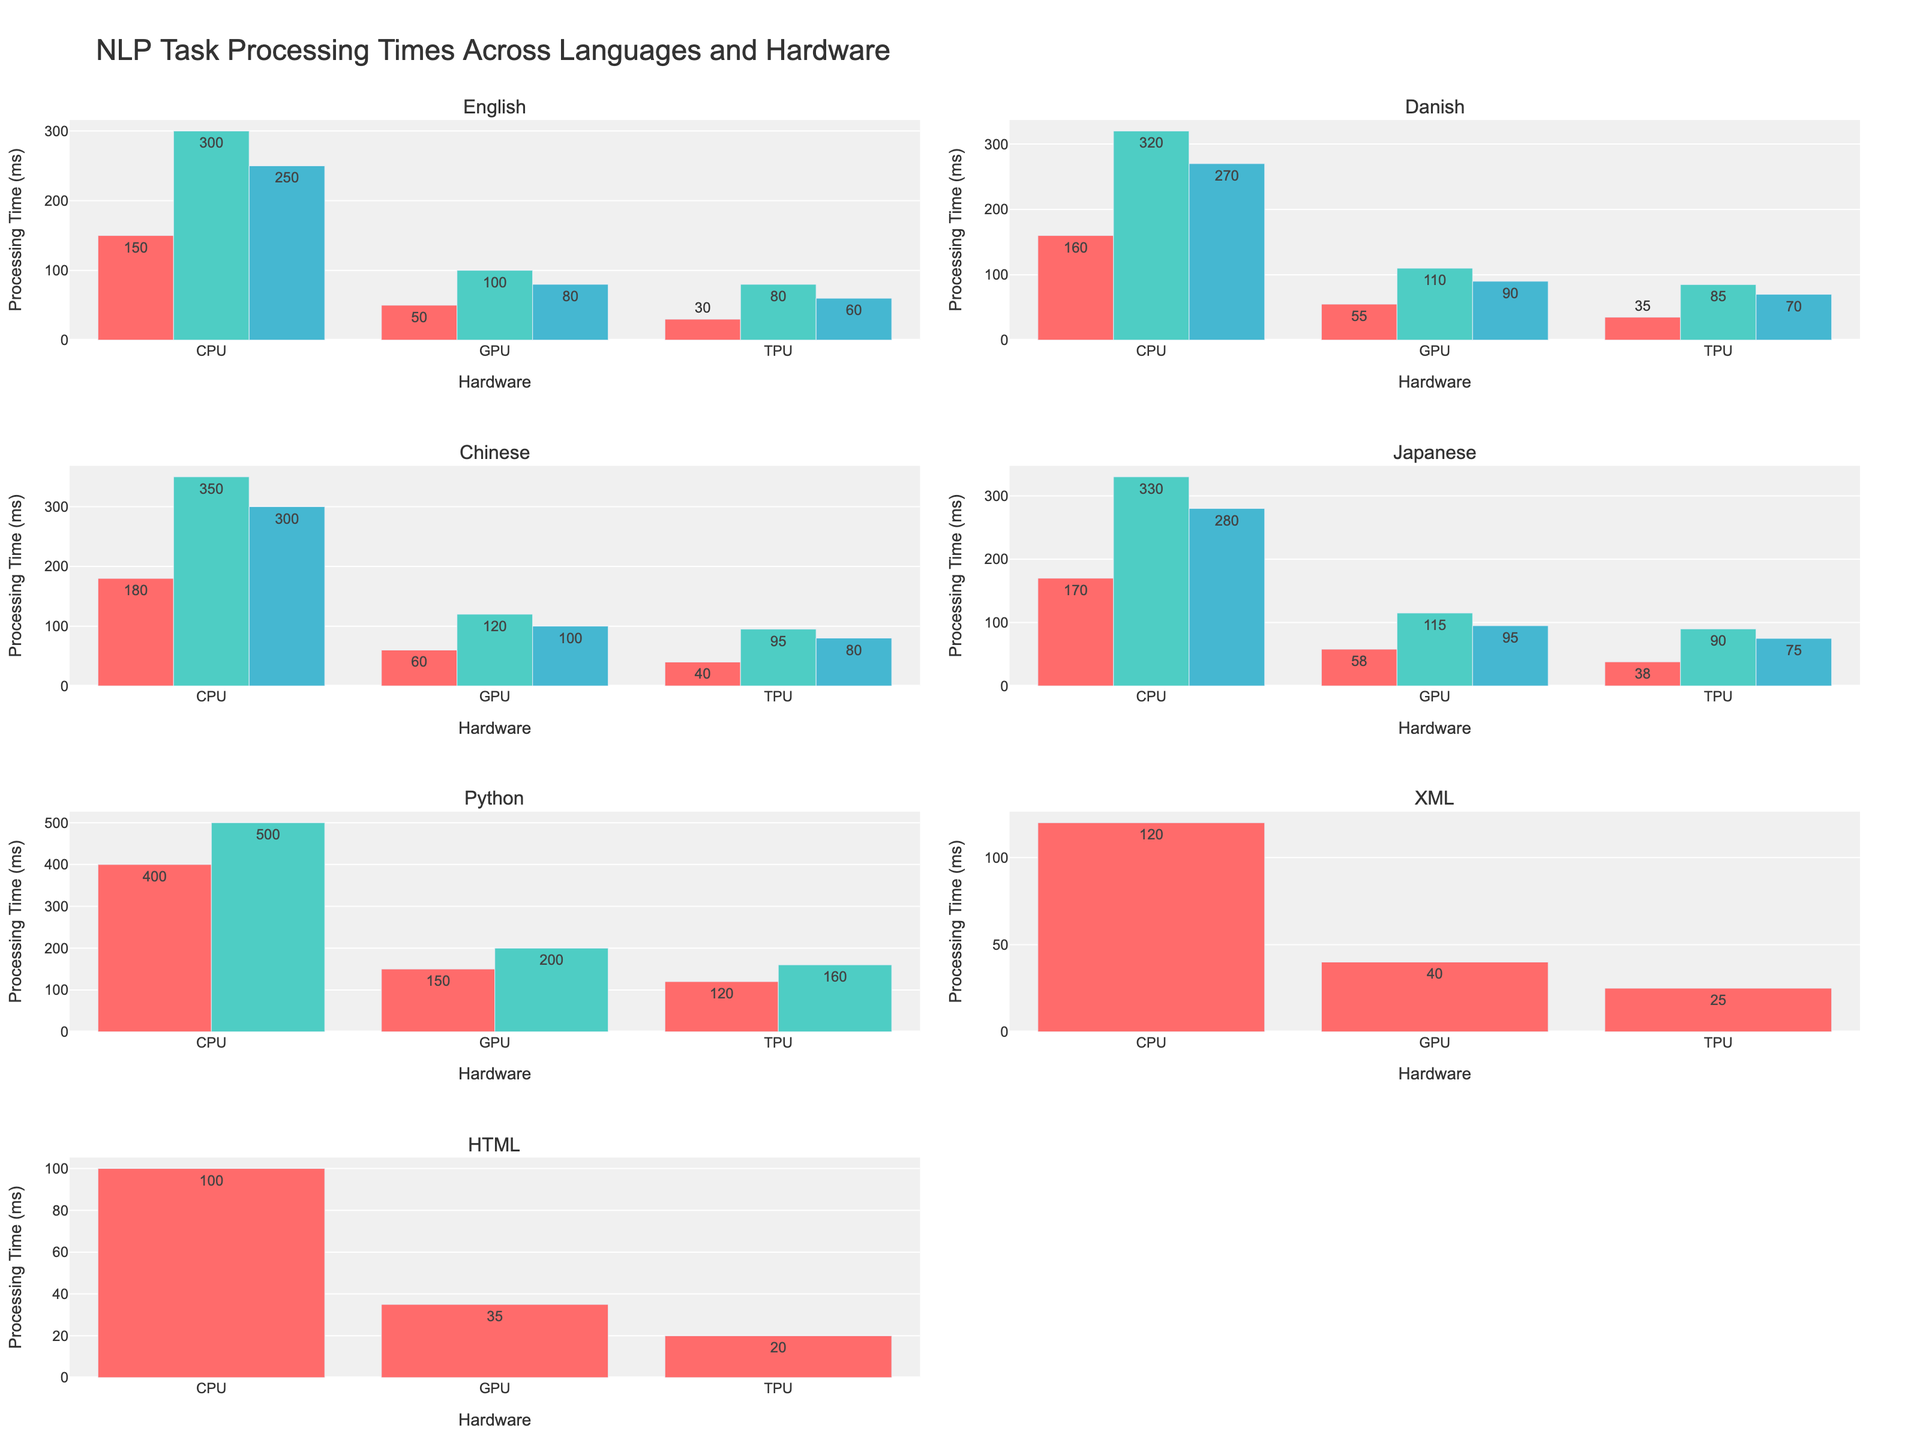What's the title of the figure? The title of the figure is located at the top and typically summarizes the content of the visual. Here, it consists of centered large text at the top of the figure.
Answer: NLP Task Processing Times Across Languages and Hardware Which hardware configuration has the fastest processing time for the English Tokenization task? For English Tokenization, the bar corresponding to TPU has the shortest height, indicating that TPU has the lowest processing time.
Answer: TPU What is the processing time difference between CPU and GPU for Named Entity Recognition in Chinese? The processing time for CPU is 350 ms, and for GPU, it is 120 ms. The difference is calculated as 350 - 120.
Answer: 230 ms Which language has the longest processing time for Sentiment Analysis tasks on GPUs? Scanning through the GPU bar for Sentiment Analysis across languages, Chinese shows the longest bar (highest value of 100 ms).
Answer: Chinese How does the processing time for Code Generation on CPUs compare to that on GPUs? For Code Generation, the CPU processing time is 500 ms, whereas the GPU processing time is 200 ms. The CPU is significantly higher.
Answer: CPUs take longer What is the average processing time for Tokenization tasks across all hardware for Japanese? The processing times for Tokenization in Japanese are 170 ms (CPU), 58 ms (GPU), and 38 ms (TPU). The average is calculated as (170 + 58 + 38) / 3.
Answer: 88.67 ms Which task has the smallest processing time on TPUs among all the languages? Scanning through all TPU bars, the shortest bar corresponds to XML Schema Validation with 25 ms.
Answer: XML Schema Validation How do the processing times for Tokenization tasks on CPUs compare across Chinese and Japanese? The CPU processing time for Tokenization in Chinese is 180 ms, whereas for Japanese, it is 170 ms. Chinese takes longer.
Answer: Chinese takes longer Which hardware configuration provides the best performance (fastest processing) for DOM Parsing in HTML? Looking at DOM Parsing in HTML, the shortest bar belongs to TPU with 20 ms.
Answer: TPU What is the processing time difference between Named Entity Recognition and Sentiment Analysis on TPUs for Danish? The processing time for Named Entity Recognition on TPUs is 85 ms, and for Sentiment Analysis, it is 70 ms. The difference is 85 - 70.
Answer: 15 ms 